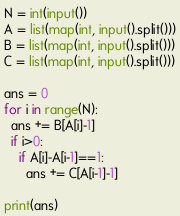<code> <loc_0><loc_0><loc_500><loc_500><_Python_>N = int(input())
A = list(map(int, input().split()))
B = list(map(int, input().split()))
C = list(map(int, input().split()))

ans = 0
for i in range(N):
  ans += B[A[i]-1]
  if i>0:
    if A[i]-A[i-1]==1:
      ans += C[A[i-1]-1]

print(ans)</code> 